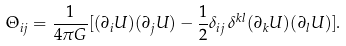Convert formula to latex. <formula><loc_0><loc_0><loc_500><loc_500>\Theta _ { i j } = \frac { 1 } { 4 \pi G } [ ( \partial _ { i } U ) ( \partial _ { j } U ) - \frac { 1 } { 2 } \delta _ { i j } \, \delta ^ { k l } ( \partial _ { k } U ) ( \partial _ { l } U ) ] .</formula> 